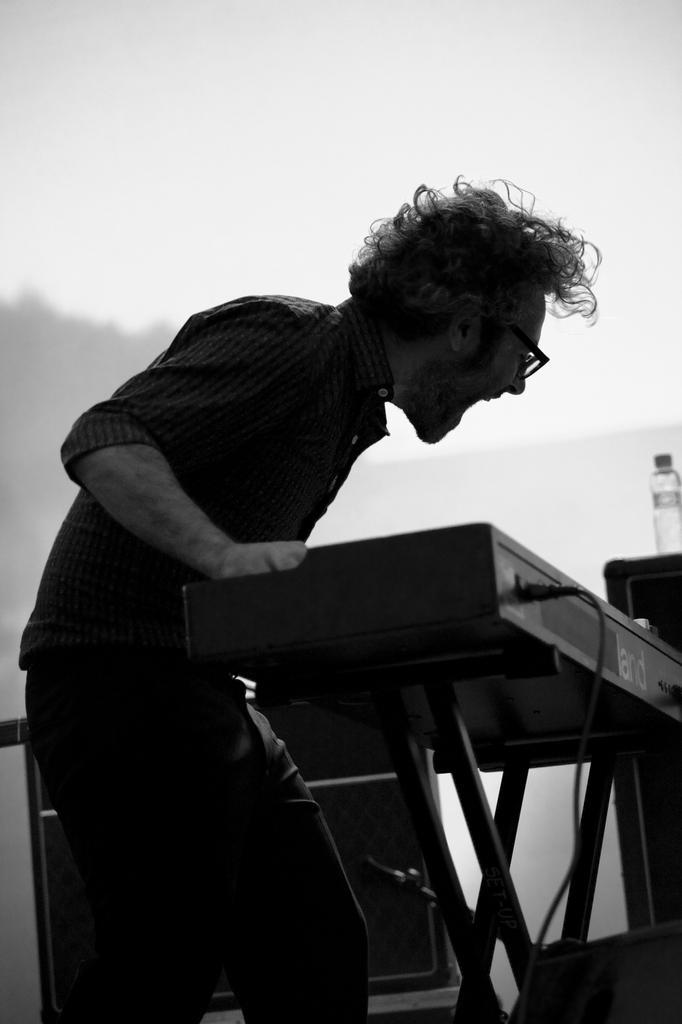Please provide a concise description of this image. In this image I can see a person standing in front of the table , on the table I can see a bottle and a cable card attached to the table ,at the top I can see white color background. 